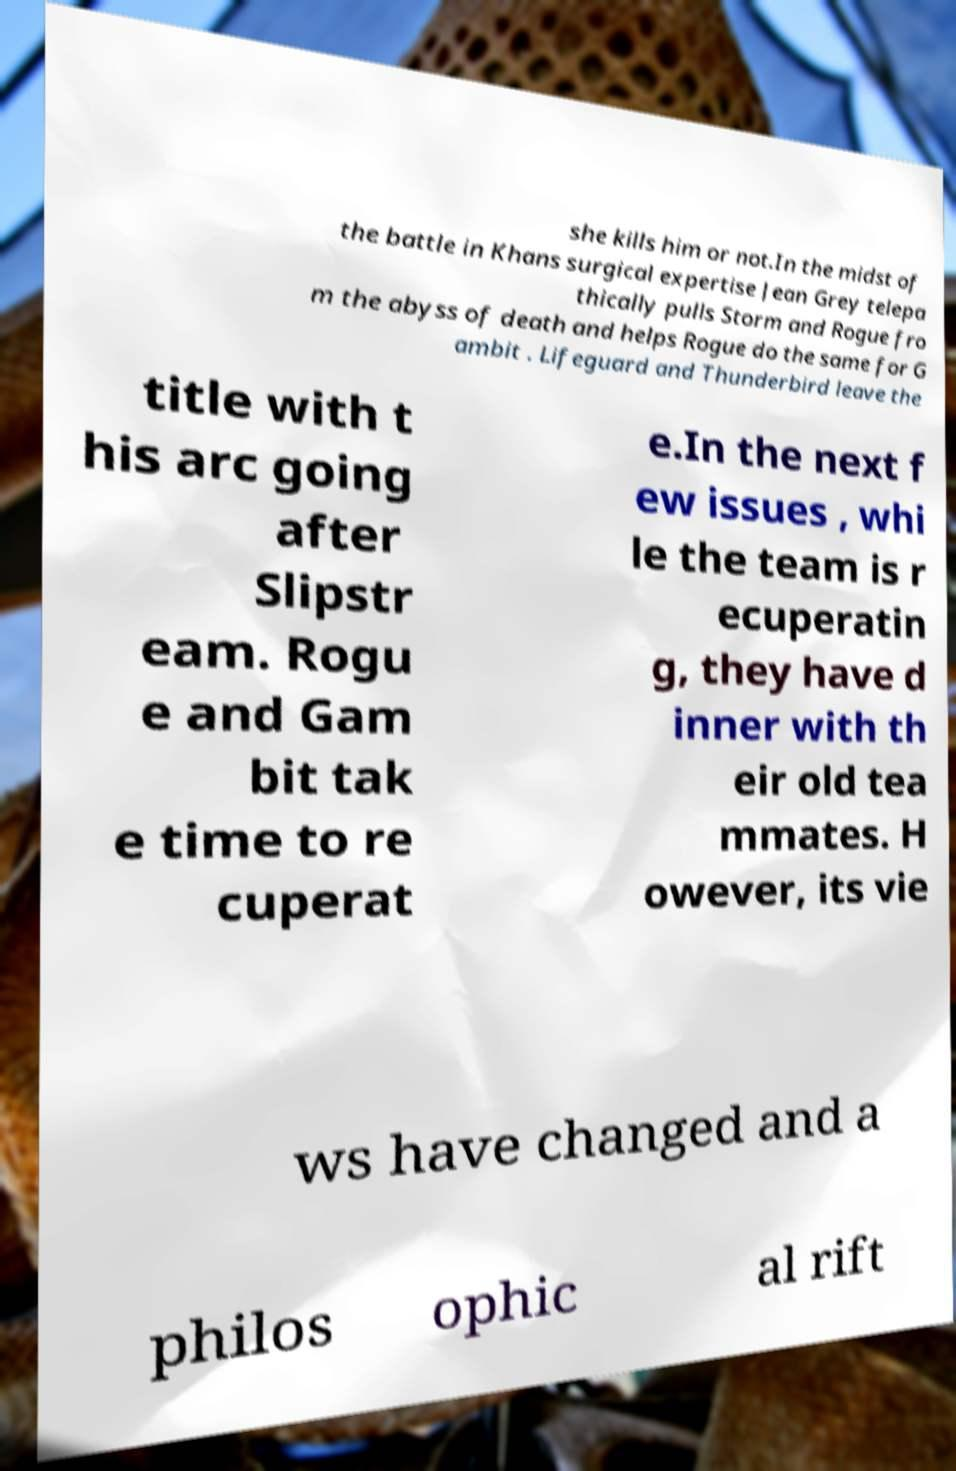Could you assist in decoding the text presented in this image and type it out clearly? she kills him or not.In the midst of the battle in Khans surgical expertise Jean Grey telepa thically pulls Storm and Rogue fro m the abyss of death and helps Rogue do the same for G ambit . Lifeguard and Thunderbird leave the title with t his arc going after Slipstr eam. Rogu e and Gam bit tak e time to re cuperat e.In the next f ew issues , whi le the team is r ecuperatin g, they have d inner with th eir old tea mmates. H owever, its vie ws have changed and a philos ophic al rift 